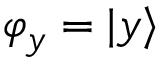<formula> <loc_0><loc_0><loc_500><loc_500>\varphi _ { y } = | y \rangle</formula> 